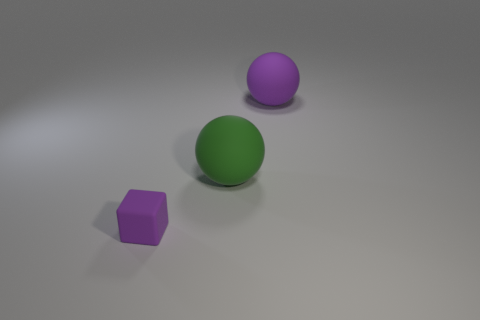Add 1 tiny matte cubes. How many objects exist? 4 Subtract all purple spheres. How many spheres are left? 1 Subtract all cubes. How many objects are left? 2 Add 2 large purple rubber balls. How many large purple rubber balls are left? 3 Add 3 big red spheres. How many big red spheres exist? 3 Subtract 0 purple cylinders. How many objects are left? 3 Subtract 1 cubes. How many cubes are left? 0 Subtract all blue cubes. Subtract all red cylinders. How many cubes are left? 1 Subtract all brown cubes. How many cyan spheres are left? 0 Subtract all large green cylinders. Subtract all rubber things. How many objects are left? 0 